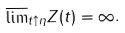<formula> <loc_0><loc_0><loc_500><loc_500>\overline { \lim } _ { t \uparrow \eta } Z ( t ) = \infty .</formula> 